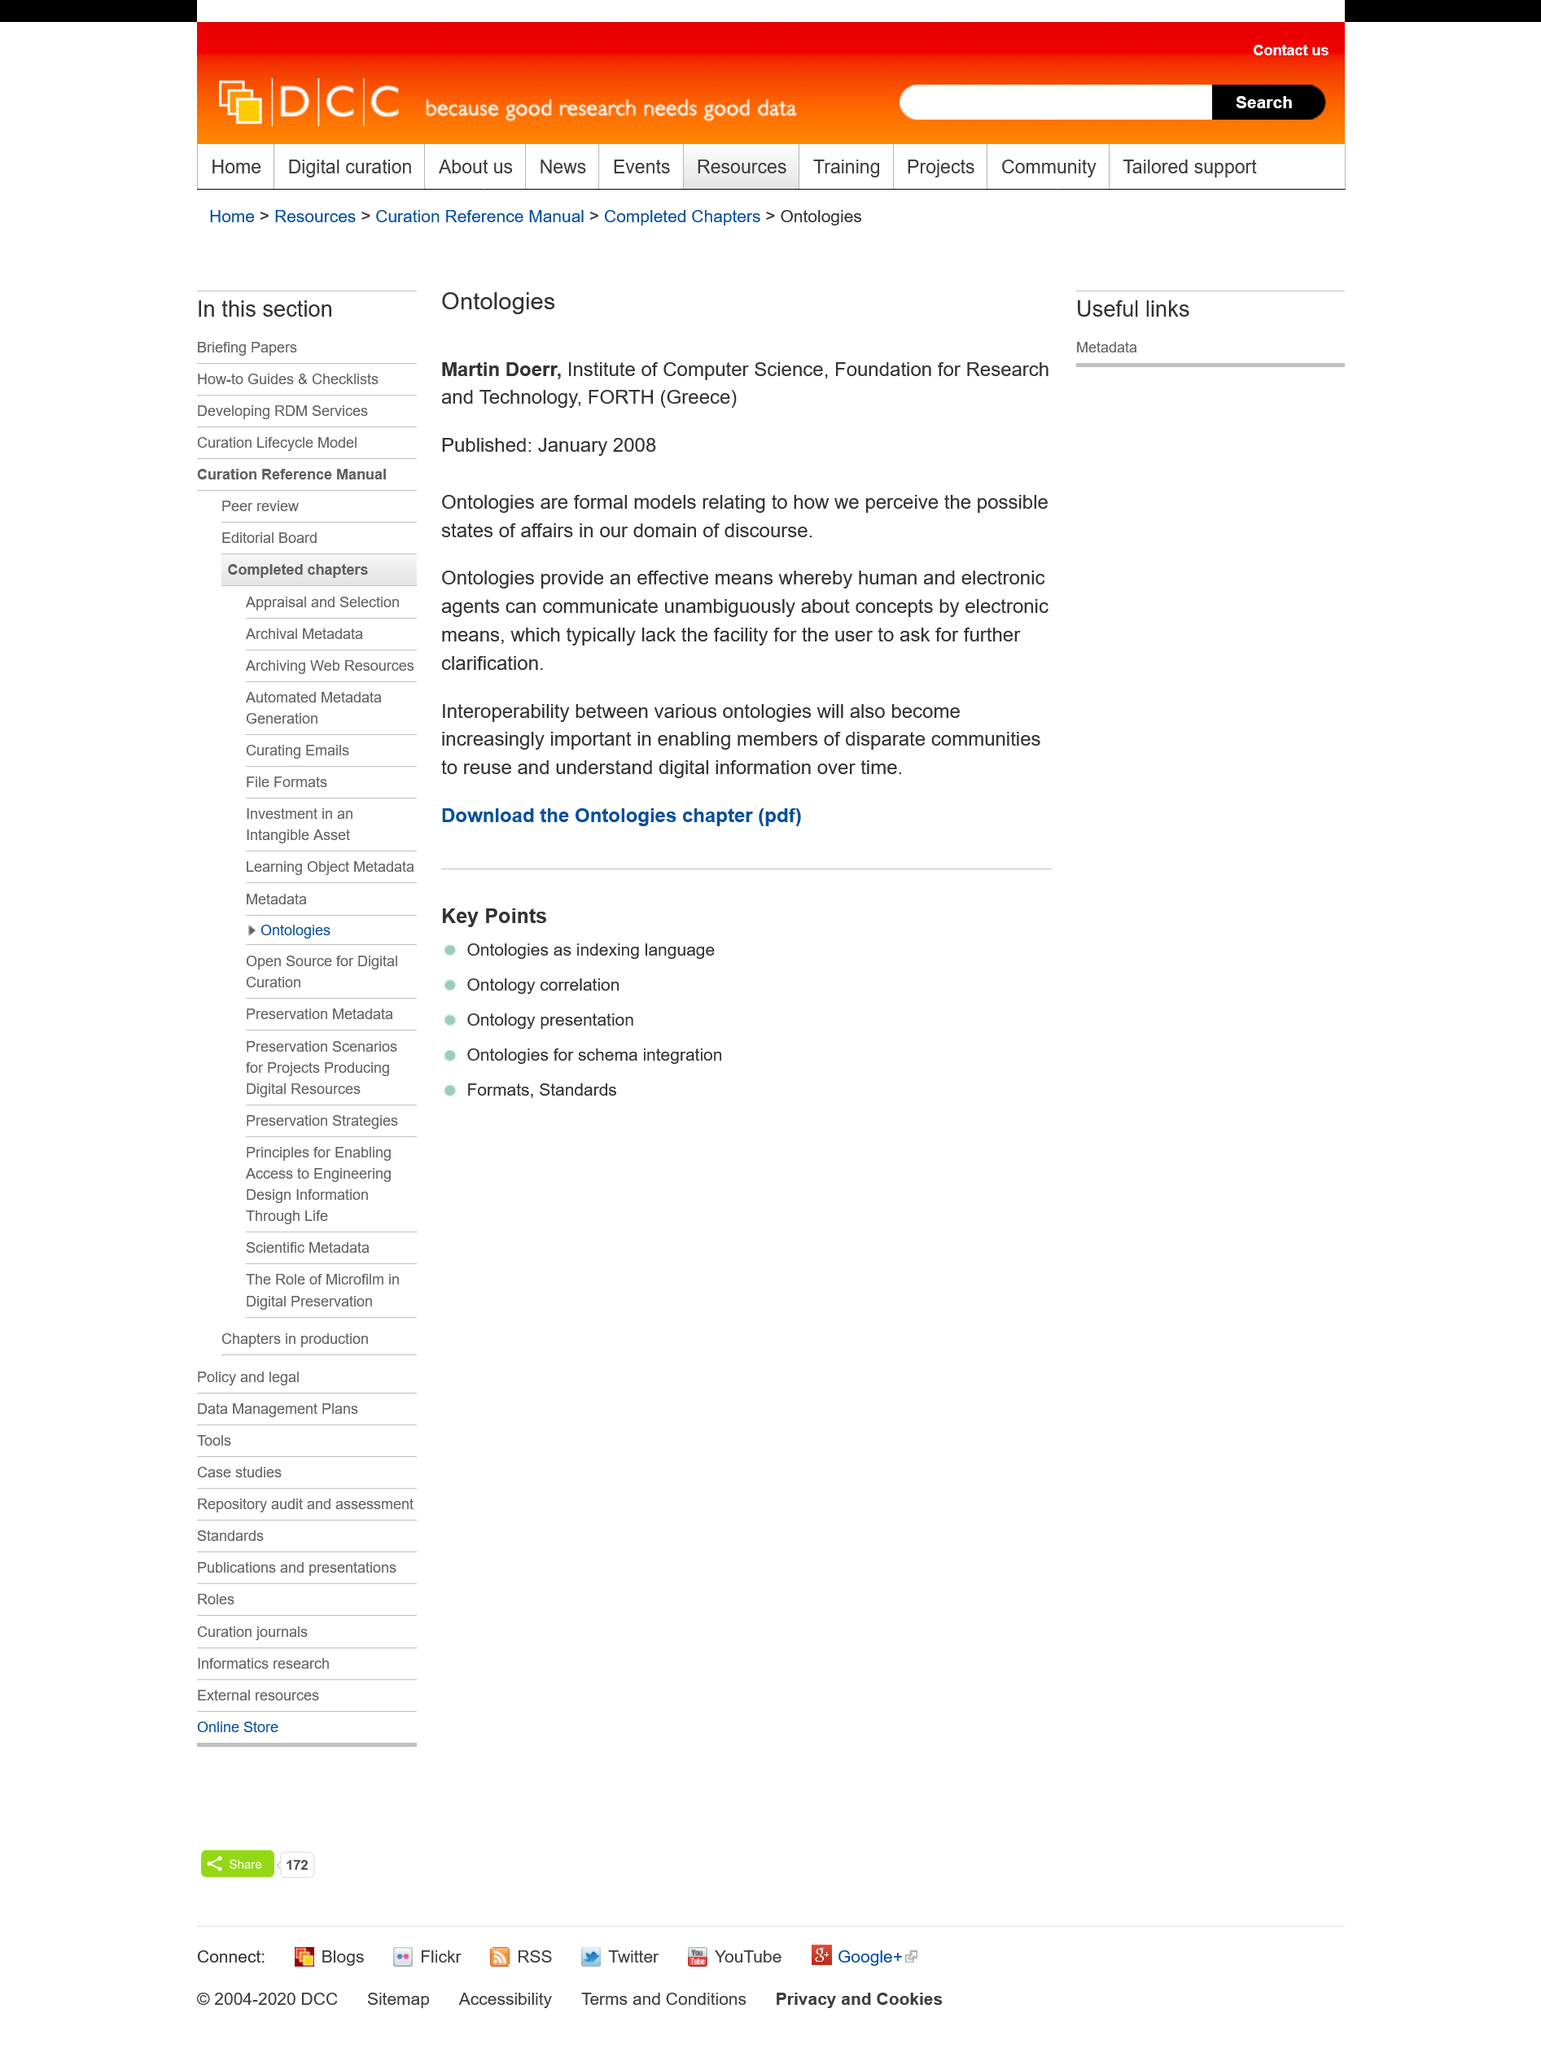Point out several critical features in this image. The article on ontologies was published in January 2008. Formal models relating to how we perceive the possible state of affairs in our domain of discourse are known as ontologies. FORTH stands for Foundation for Research and Technology. 